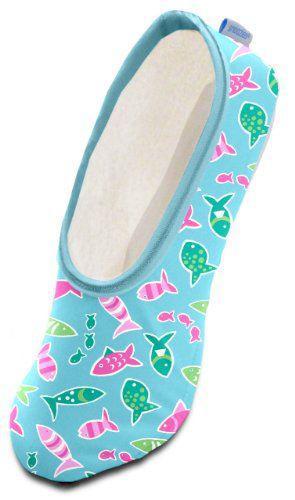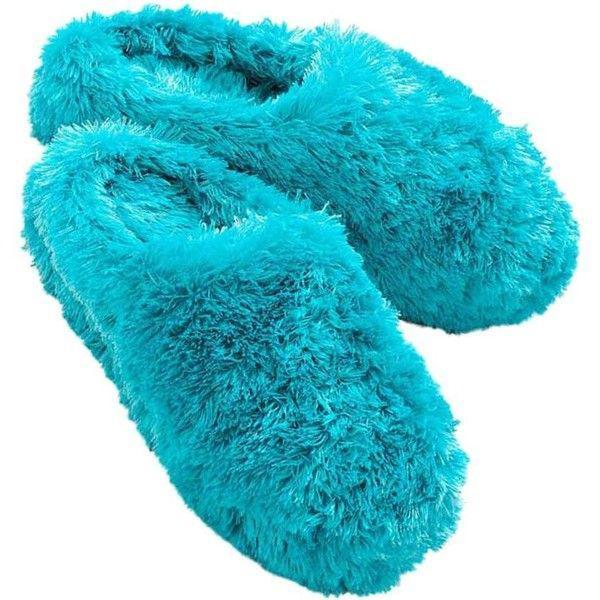The first image is the image on the left, the second image is the image on the right. Given the left and right images, does the statement "there is a pair of slippers with on on its side, with eyes on the front" hold true? Answer yes or no. No. The first image is the image on the left, the second image is the image on the right. Analyze the images presented: Is the assertion "The left image contains a single print-patterned slipper without a fluffy texture, and the right image contains a pair of fluffy slippers." valid? Answer yes or no. Yes. 